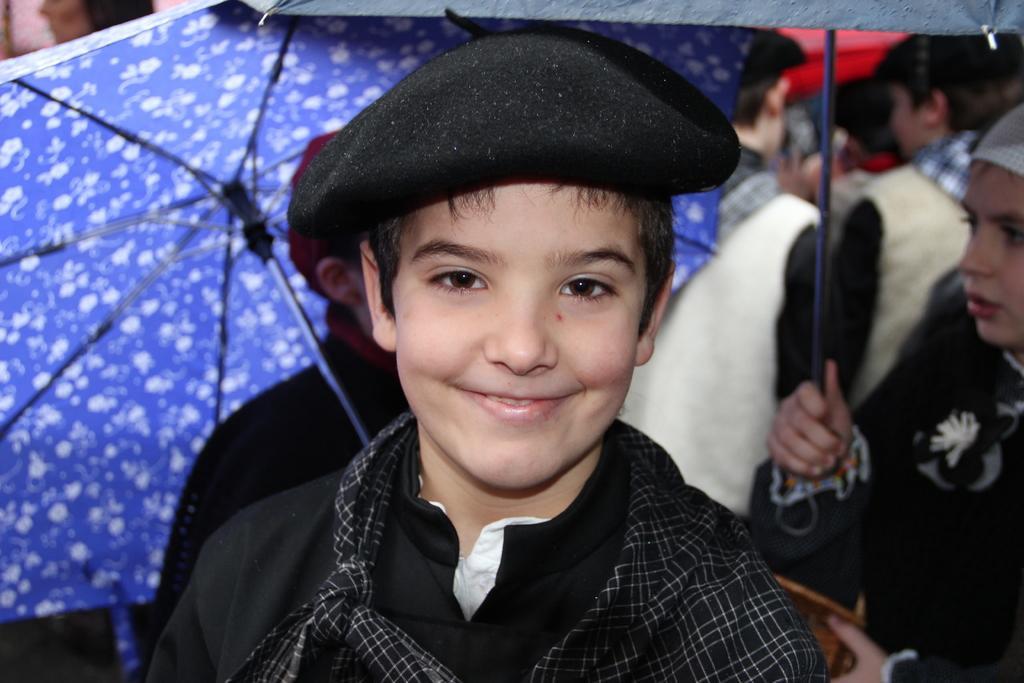Could you give a brief overview of what you see in this image? In this image there are many people. Few are holding umbrella. In the foreground a boy is standing wearing a cap. He is smiling. 